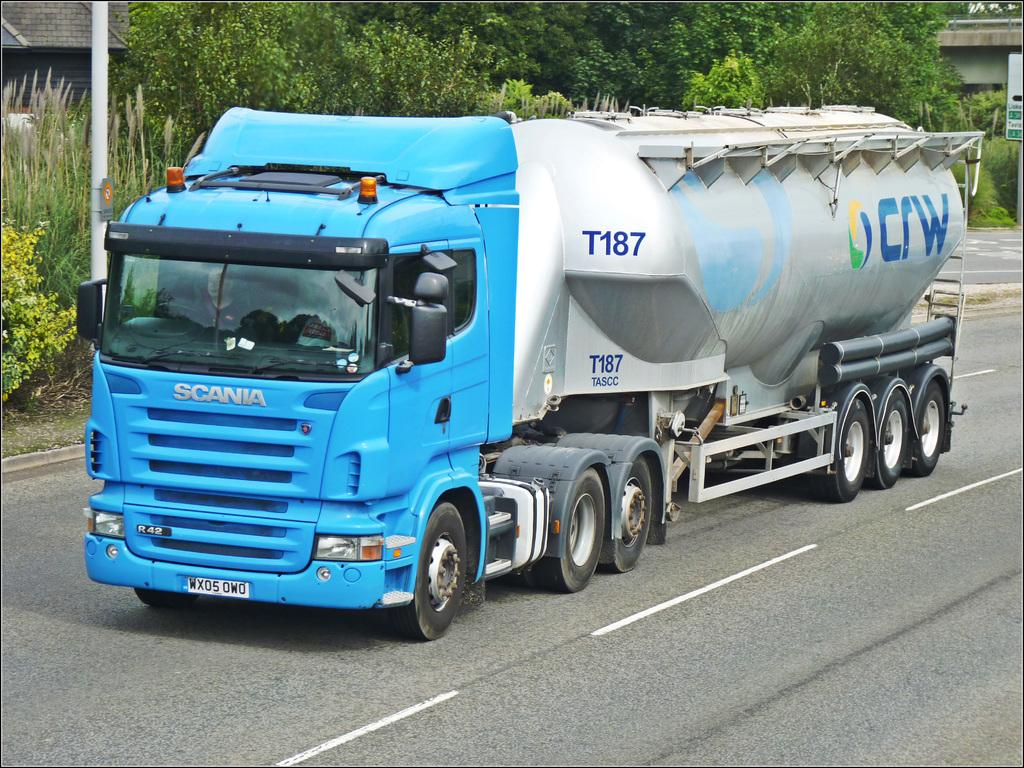What is the main subject of the image? There is a truck in the image. What color is the truck? The truck is blue in color. What is at the bottom of the image? There is a road at the bottom of the image. What can be seen in the background of the image? There are trees, a pole, and houses in the background of the image. What type of veil can be seen hanging from the pole in the image? There is no veil present in the image; the pole is in the background of the image, but no veil is attached to it. 